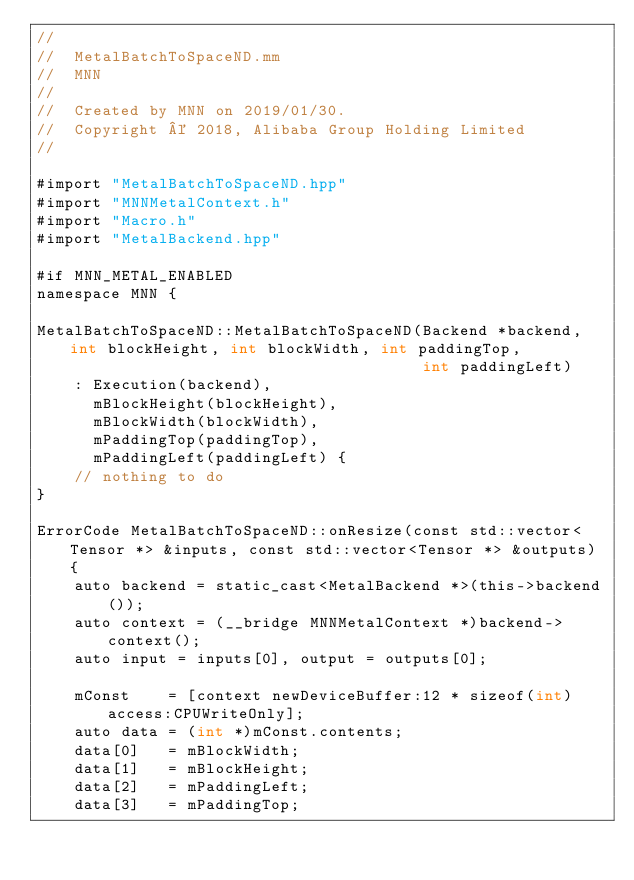<code> <loc_0><loc_0><loc_500><loc_500><_ObjectiveC_>//
//  MetalBatchToSpaceND.mm
//  MNN
//
//  Created by MNN on 2019/01/30.
//  Copyright © 2018, Alibaba Group Holding Limited
//

#import "MetalBatchToSpaceND.hpp"
#import "MNNMetalContext.h"
#import "Macro.h"
#import "MetalBackend.hpp"

#if MNN_METAL_ENABLED
namespace MNN {

MetalBatchToSpaceND::MetalBatchToSpaceND(Backend *backend, int blockHeight, int blockWidth, int paddingTop,
                                         int paddingLeft)
    : Execution(backend),
      mBlockHeight(blockHeight),
      mBlockWidth(blockWidth),
      mPaddingTop(paddingTop),
      mPaddingLeft(paddingLeft) {
    // nothing to do
}

ErrorCode MetalBatchToSpaceND::onResize(const std::vector<Tensor *> &inputs, const std::vector<Tensor *> &outputs) {
    auto backend = static_cast<MetalBackend *>(this->backend());
    auto context = (__bridge MNNMetalContext *)backend->context();
    auto input = inputs[0], output = outputs[0];

    mConst    = [context newDeviceBuffer:12 * sizeof(int) access:CPUWriteOnly];
    auto data = (int *)mConst.contents;
    data[0]   = mBlockWidth;
    data[1]   = mBlockHeight;
    data[2]   = mPaddingLeft;
    data[3]   = mPaddingTop;</code> 